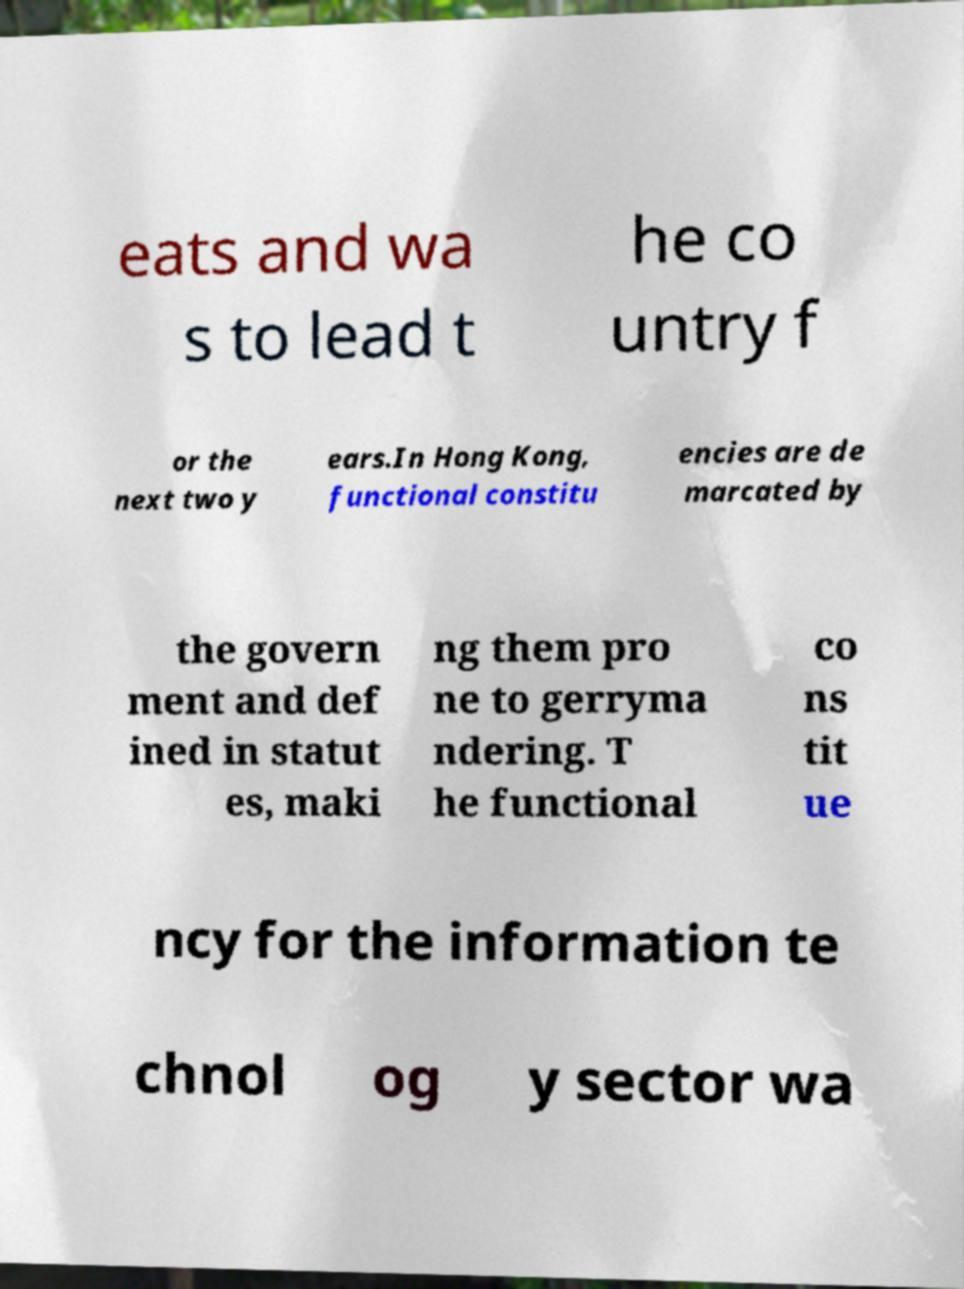For documentation purposes, I need the text within this image transcribed. Could you provide that? eats and wa s to lead t he co untry f or the next two y ears.In Hong Kong, functional constitu encies are de marcated by the govern ment and def ined in statut es, maki ng them pro ne to gerryma ndering. T he functional co ns tit ue ncy for the information te chnol og y sector wa 